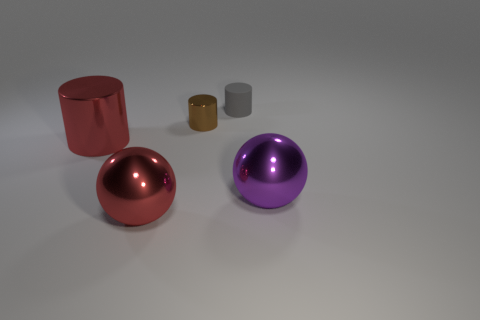What color is the metallic ball on the right side of the small cylinder that is on the right side of the brown cylinder?
Give a very brief answer. Purple. Are any large metallic cubes visible?
Make the answer very short. No. Is the brown thing the same shape as the rubber thing?
Make the answer very short. Yes. There is a object that is the same color as the big cylinder; what is its size?
Provide a short and direct response. Large. There is a cylinder that is in front of the brown cylinder; what number of brown things are in front of it?
Offer a very short reply. 0. What number of large objects are both in front of the large metal cylinder and on the left side of the tiny rubber thing?
Your answer should be very brief. 1. What number of objects are gray things or large spheres in front of the large red metallic cylinder?
Offer a very short reply. 3. What size is the red thing that is made of the same material as the red cylinder?
Provide a short and direct response. Large. What is the shape of the thing that is to the left of the shiny sphere left of the tiny shiny thing?
Keep it short and to the point. Cylinder. How many green objects are metal things or large metal cylinders?
Give a very brief answer. 0. 